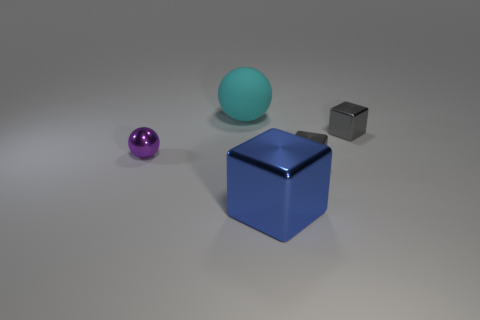How many other objects are the same color as the metallic ball?
Offer a very short reply. 0. There is a gray shiny cube behind the metallic thing left of the large blue object that is in front of the large ball; what is its size?
Provide a short and direct response. Small. There is a large blue cube; are there any big objects behind it?
Keep it short and to the point. Yes. Is the size of the shiny sphere the same as the gray block behind the small ball?
Offer a very short reply. Yes. What number of other things are made of the same material as the large cyan sphere?
Keep it short and to the point. 0. The object that is on the left side of the blue metallic cube and in front of the large matte ball has what shape?
Your answer should be very brief. Sphere. Does the metallic thing that is left of the big blue thing have the same size as the blue shiny object in front of the matte thing?
Your answer should be compact. No. There is a purple object that is made of the same material as the big blue thing; what shape is it?
Keep it short and to the point. Sphere. Is there any other thing that is the same shape as the blue thing?
Ensure brevity in your answer.  Yes. What is the color of the large object that is in front of the thing that is behind the tiny block that is behind the purple ball?
Provide a short and direct response. Blue. 